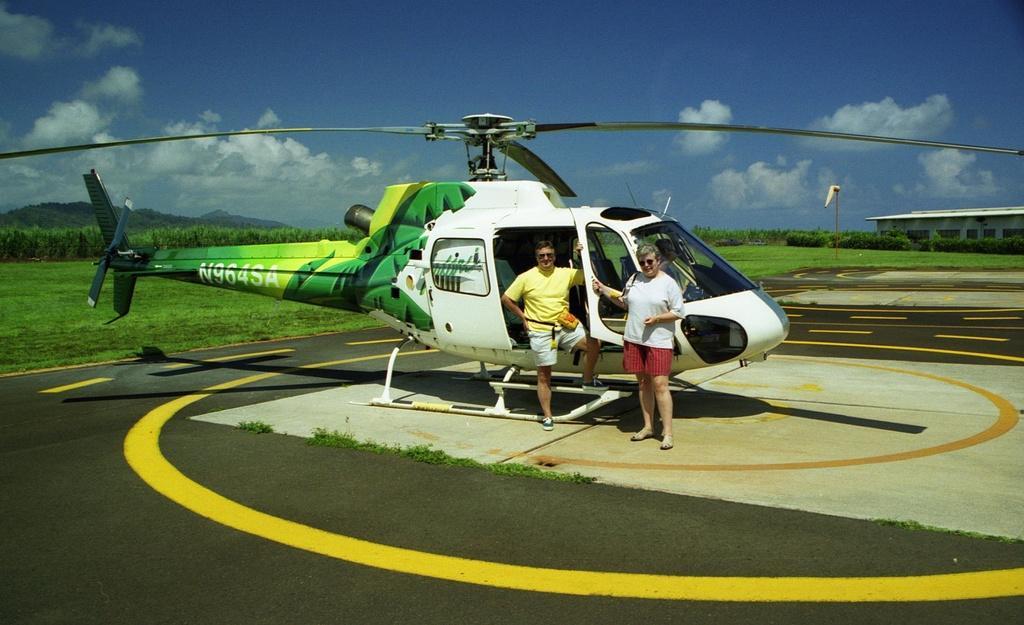Can you describe this image briefly? In this image we can see two persons and a helicopter on the road. Here we can see grass, plants, pole, and a shed. In the background there is sky with clouds. 